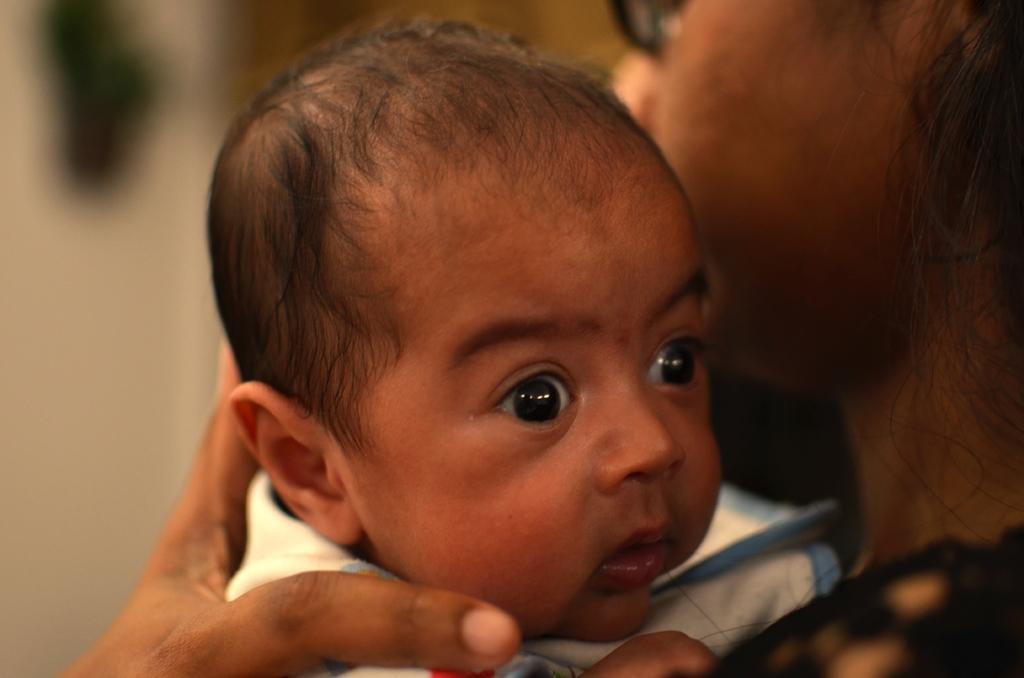Can you describe this image briefly? In the picture there is a woman carrying a baby. 